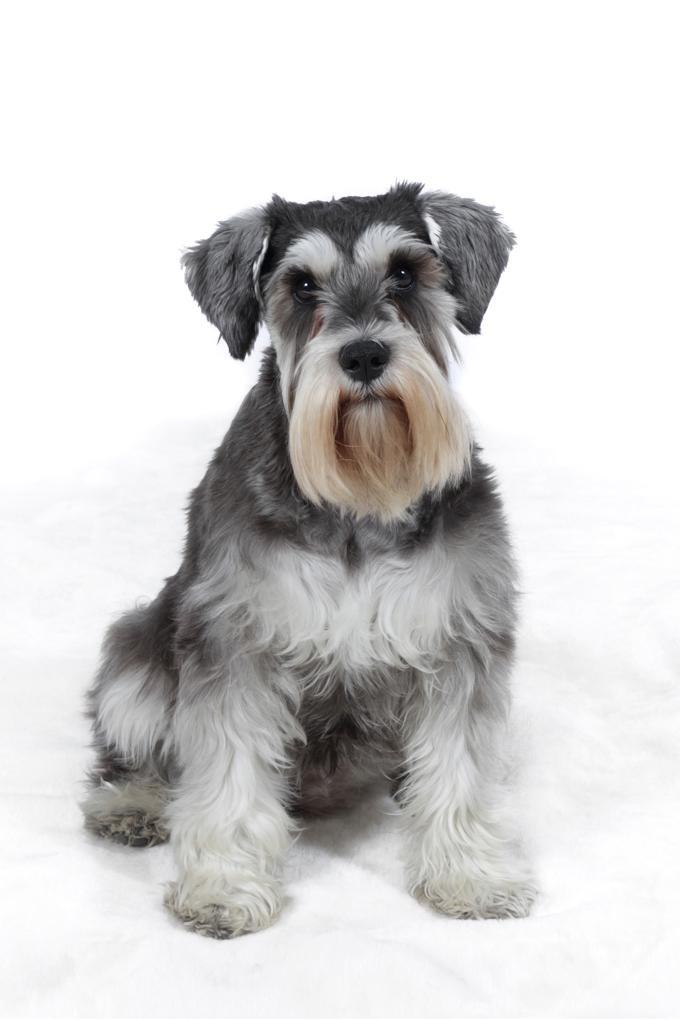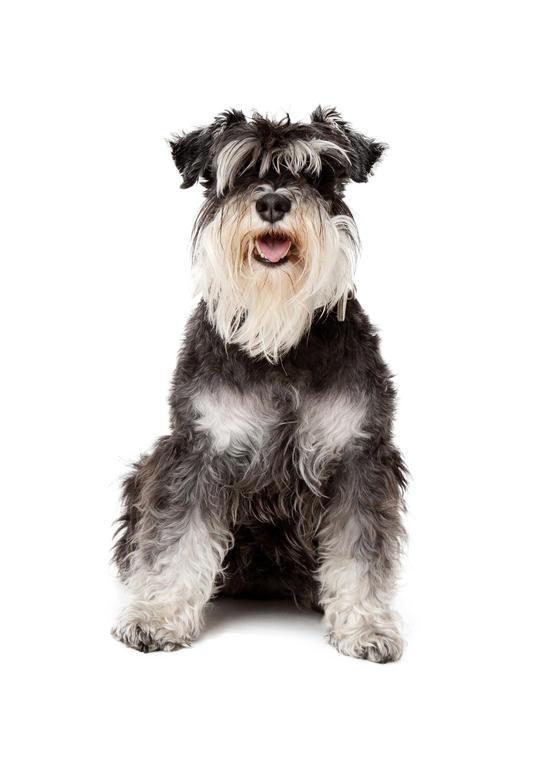The first image is the image on the left, the second image is the image on the right. For the images displayed, is the sentence "There are two dogs sitting down" factually correct? Answer yes or no. Yes. 